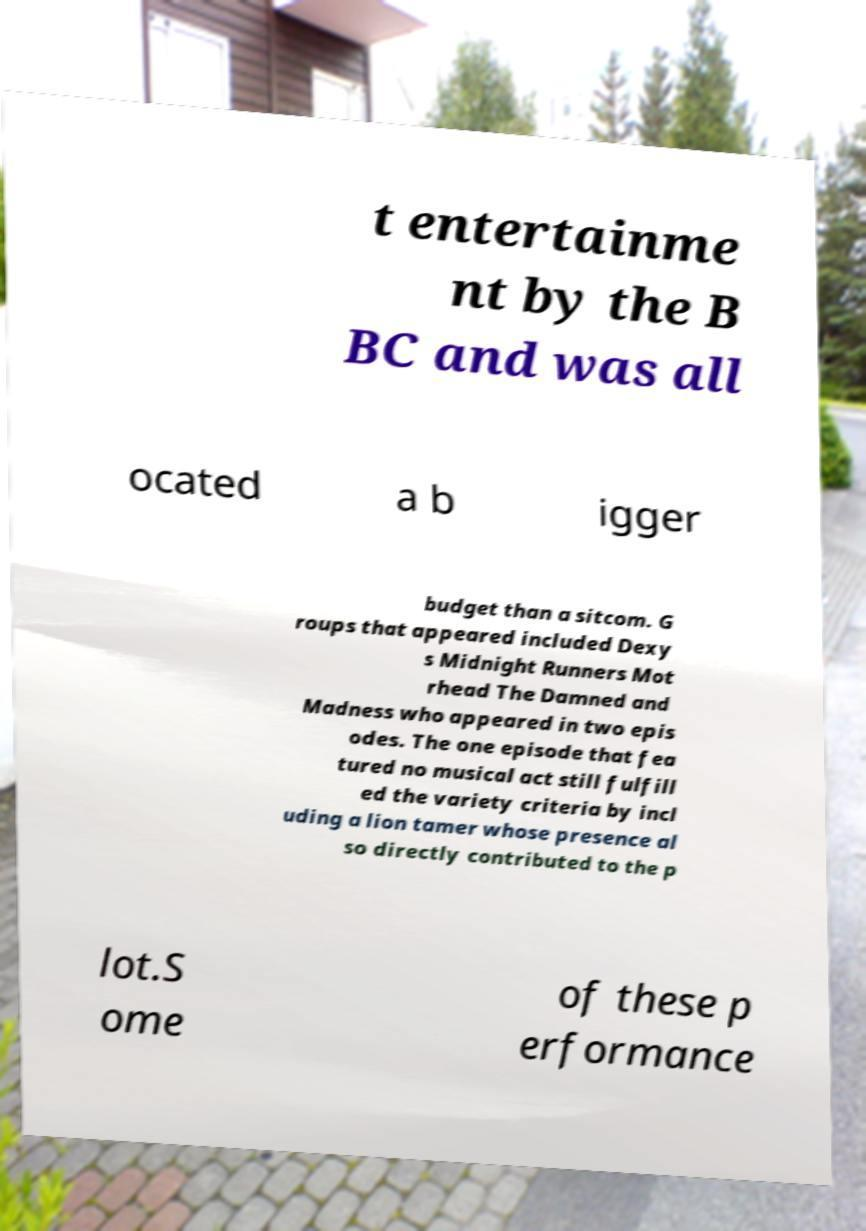What messages or text are displayed in this image? I need them in a readable, typed format. t entertainme nt by the B BC and was all ocated a b igger budget than a sitcom. G roups that appeared included Dexy s Midnight Runners Mot rhead The Damned and Madness who appeared in two epis odes. The one episode that fea tured no musical act still fulfill ed the variety criteria by incl uding a lion tamer whose presence al so directly contributed to the p lot.S ome of these p erformance 